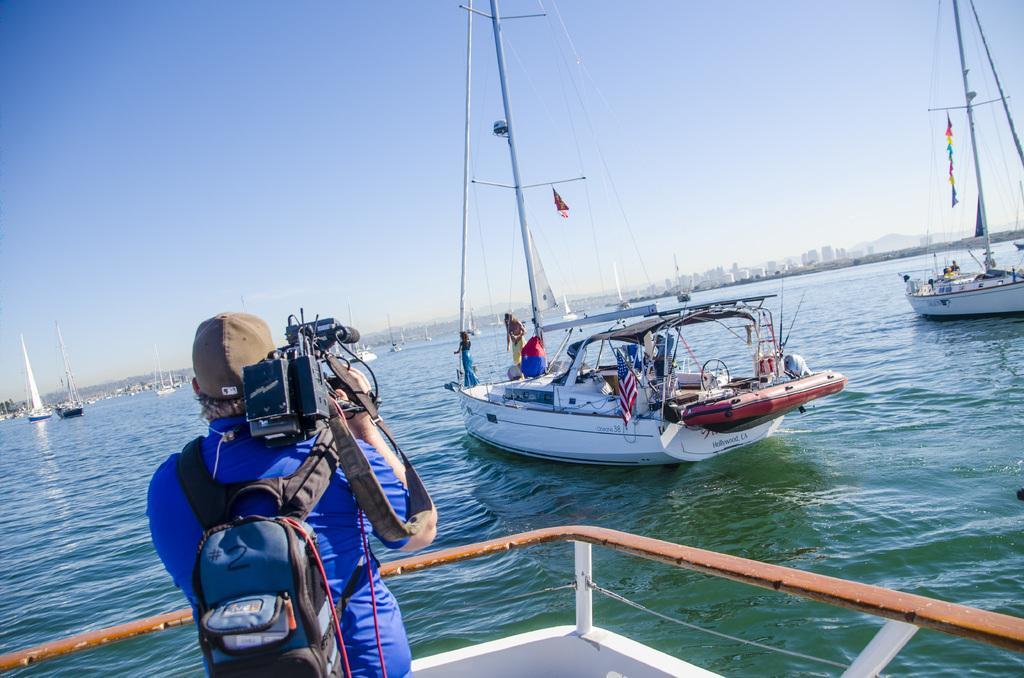Describe this image in one or two sentences. In this picture we can see some ships floating in the water, one person is carrying a bag and holding camera, in another ship we can see two persons are standing. 